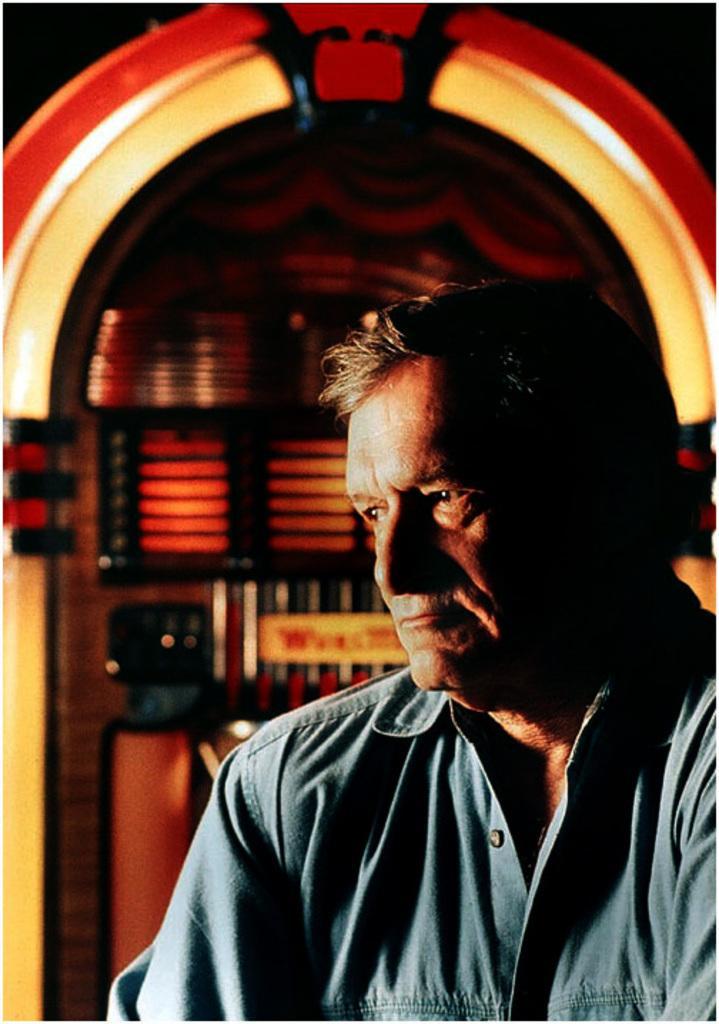In one or two sentences, can you explain what this image depicts? There is a man,In the background we can see wall. 